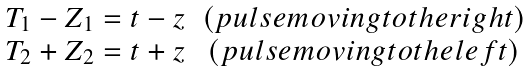Convert formula to latex. <formula><loc_0><loc_0><loc_500><loc_500>\begin{array} { c c } T _ { 1 } - Z _ { 1 } = t - z & ( p u l s e m o v i n g t o t h e r i g h t ) \\ T _ { 2 } + Z _ { 2 } = t + z & ( p u l s e m o v i n g t o t h e l e f t ) \end{array}</formula> 